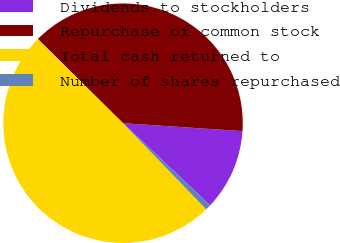Convert chart to OTSL. <chart><loc_0><loc_0><loc_500><loc_500><pie_chart><fcel>Dividends to stockholders<fcel>Repurchase of common stock<fcel>Total cash returned to<fcel>Number of shares repurchased<nl><fcel>10.98%<fcel>38.65%<fcel>49.63%<fcel>0.74%<nl></chart> 